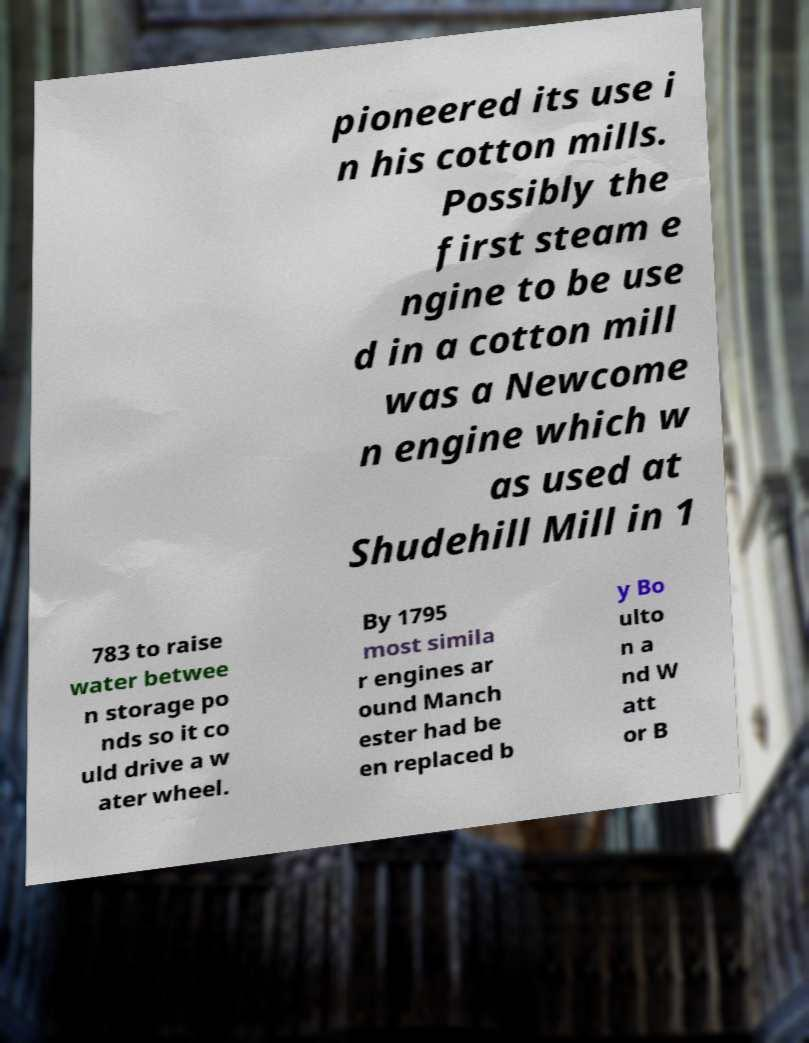Can you read and provide the text displayed in the image?This photo seems to have some interesting text. Can you extract and type it out for me? pioneered its use i n his cotton mills. Possibly the first steam e ngine to be use d in a cotton mill was a Newcome n engine which w as used at Shudehill Mill in 1 783 to raise water betwee n storage po nds so it co uld drive a w ater wheel. By 1795 most simila r engines ar ound Manch ester had be en replaced b y Bo ulto n a nd W att or B 